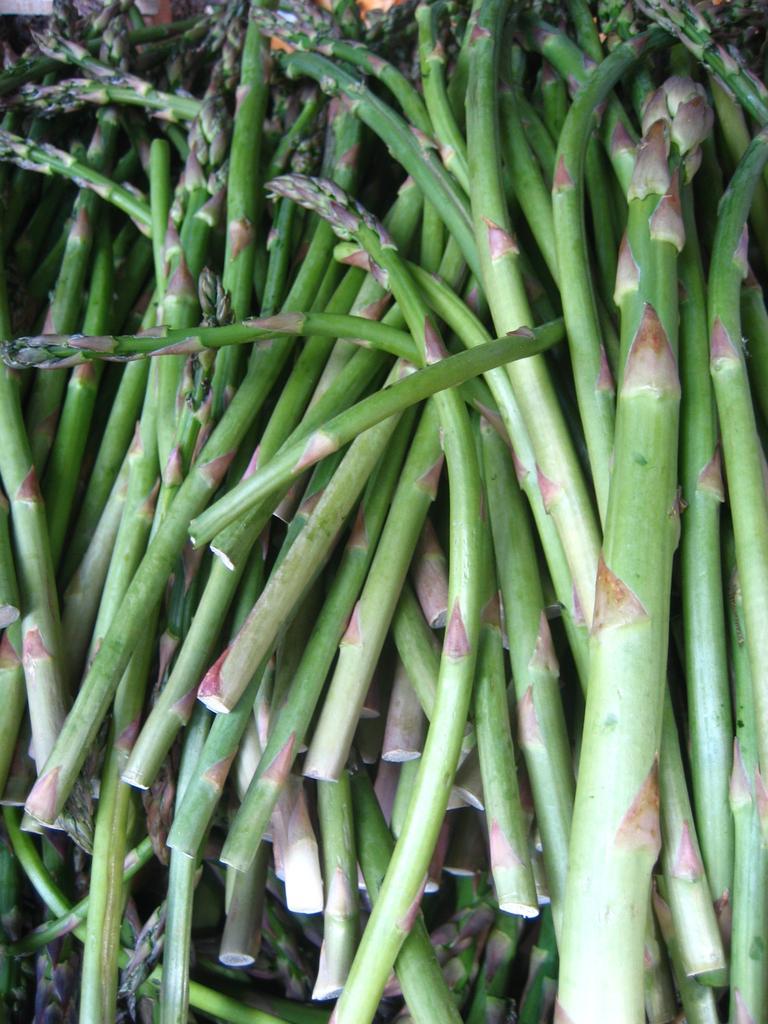Describe this image in one or two sentences. In this image we can see many steps, they are in green color. 